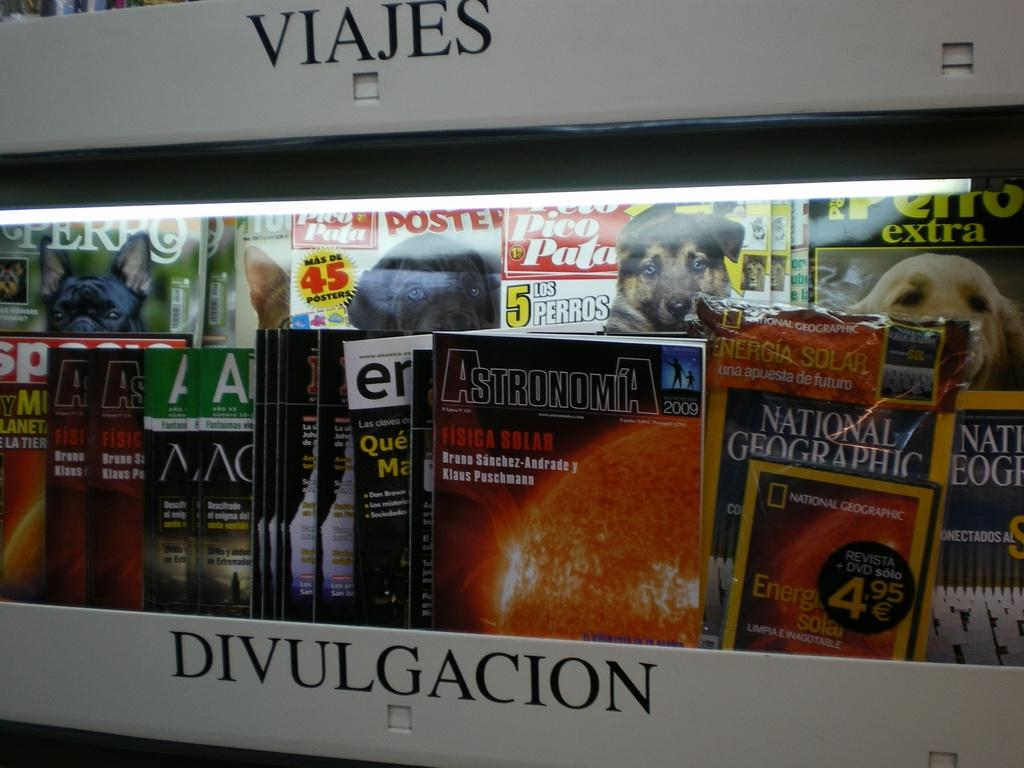What can be seen on the shelf in the image? There is text on the shelf and books on the shelf. What is written on the books? There is text on the books, and some of them have numbers on them. What else can be seen on the books? There are images of dogs on the books. Is there a maid cleaning the shelf in the image? There is no maid present in the image. Can you see a robin perched on the books in the image? There is no robin present in the image. 